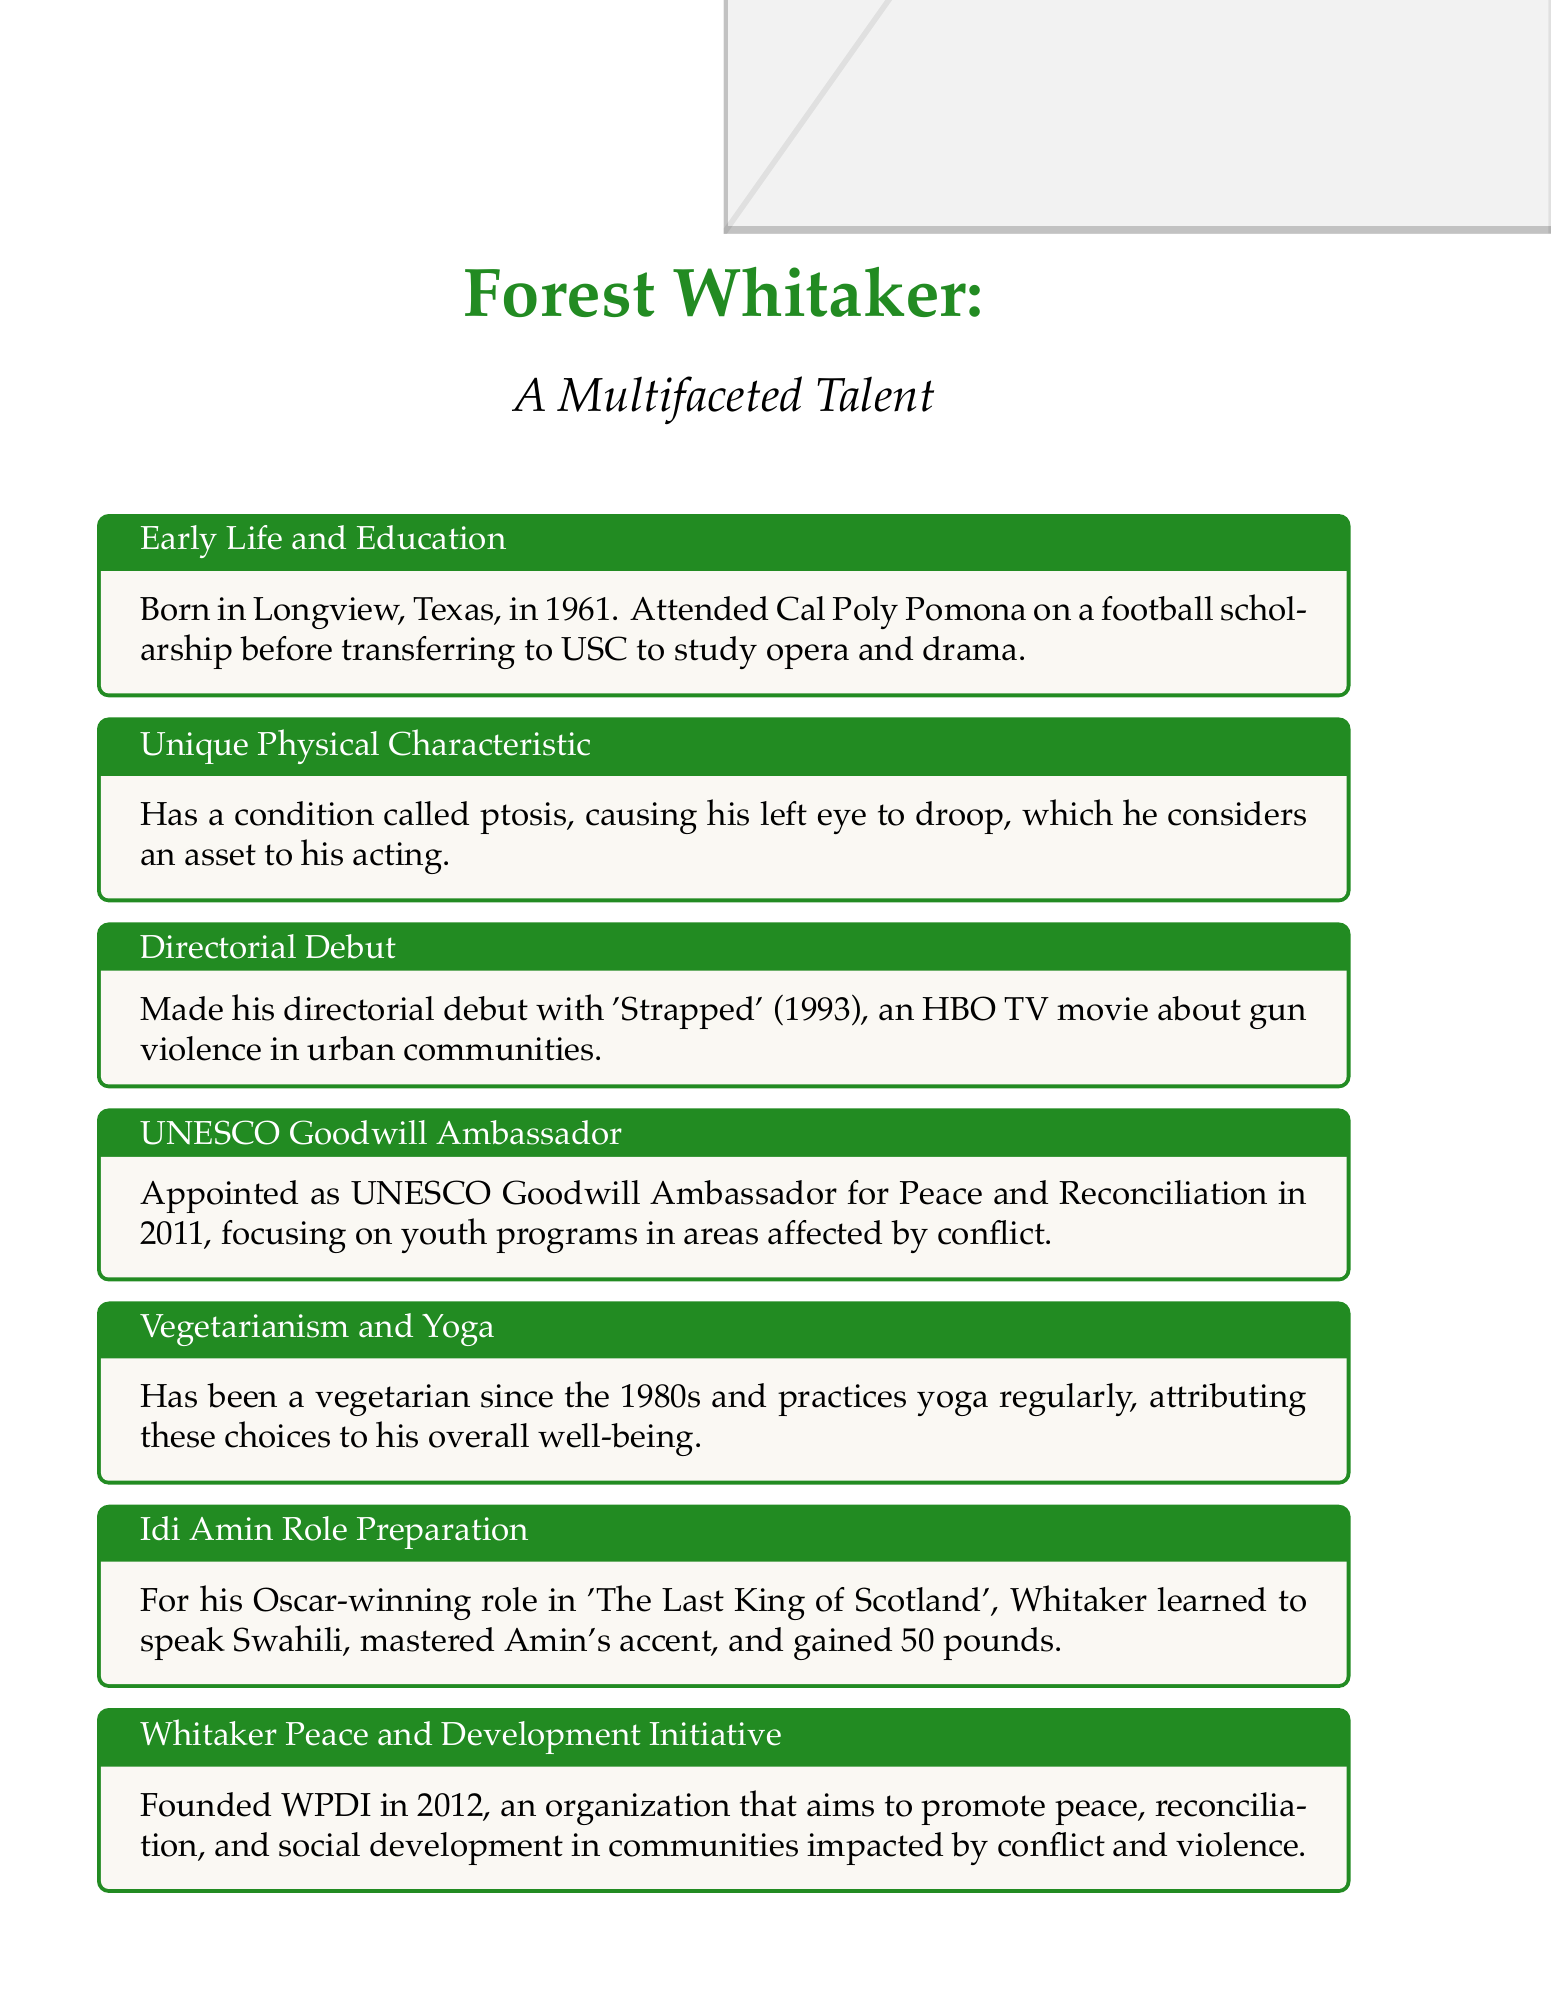What year was Forest Whitaker born? The document states that Forest Whitaker was born in 1961.
Answer: 1961 What was Forest Whitaker's major in college? According to the document, he studied opera and drama at USC.
Answer: opera and drama What role did Forest Whitaker win an Oscar for? The document mentions that he won an Oscar for his role in 'The Last King of Scotland'.
Answer: 'The Last King of Scotland' In what year did he become a UNESCO Goodwill Ambassador? The document specifies that he was appointed in 2011.
Answer: 2011 What organization did Forest Whitaker found in 2012? The document notes he founded the Whitaker Peace and Development Initiative (WPDI).
Answer: WPDI How much weight did Forest Whitaker gain for his Oscar-winning role? The document states he gained 50 pounds for the role.
Answer: 50 pounds What unique physical characteristic does Forest Whitaker have? The document indicates he has a condition called ptosis, causing his left eye to droop.
Answer: ptosis What lifestyle choices does Forest Whitaker attribute to his overall well-being? According to the document, he practices vegetarianism and yoga for his health.
Answer: vegetarianism and yoga 